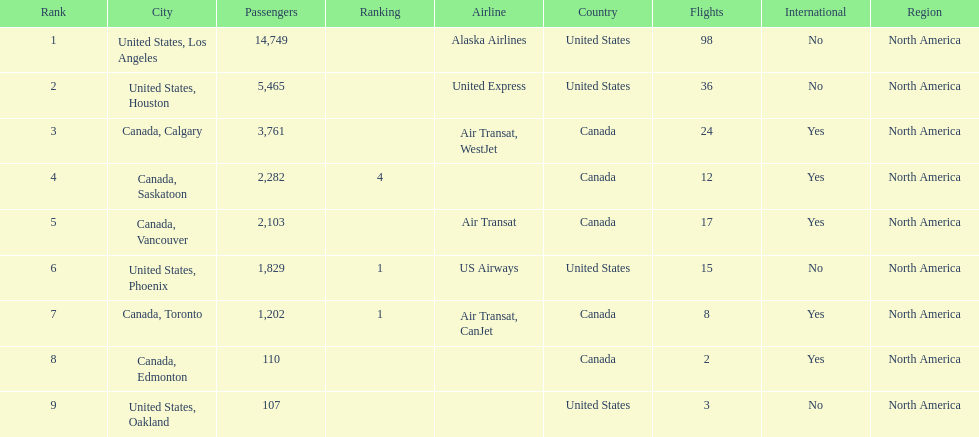What was the number of passengers in phoenix arizona? 1,829. Could you parse the entire table as a dict? {'header': ['Rank', 'City', 'Passengers', 'Ranking', 'Airline', 'Country', 'Flights', 'International', 'Region'], 'rows': [['1', 'United States, Los Angeles', '14,749', '', 'Alaska Airlines', 'United States', '98', 'No', 'North America'], ['2', 'United States, Houston', '5,465', '', 'United Express', 'United States', '36', 'No', 'North America'], ['3', 'Canada, Calgary', '3,761', '', 'Air Transat, WestJet', 'Canada', '24', 'Yes', 'North America'], ['4', 'Canada, Saskatoon', '2,282', '4', '', 'Canada', '12', 'Yes', 'North America'], ['5', 'Canada, Vancouver', '2,103', '', 'Air Transat', 'Canada', '17', 'Yes', 'North America'], ['6', 'United States, Phoenix', '1,829', '1', 'US Airways', 'United States', '15', 'No', 'North America'], ['7', 'Canada, Toronto', '1,202', '1', 'Air Transat, CanJet', 'Canada', '8', 'Yes', 'North America'], ['8', 'Canada, Edmonton', '110', '', '', 'Canada', '2', 'Yes', 'North America'], ['9', 'United States, Oakland', '107', '', '', 'United States', '3', 'No', 'North America']]} 